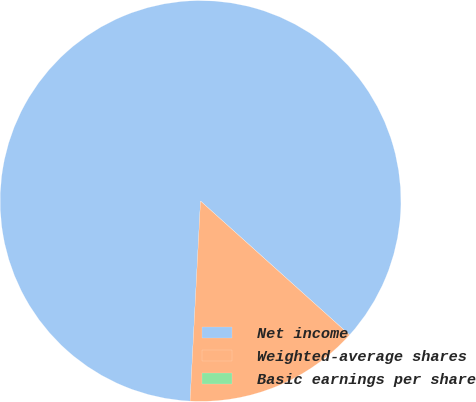Convert chart. <chart><loc_0><loc_0><loc_500><loc_500><pie_chart><fcel>Net income<fcel>Weighted-average shares<fcel>Basic earnings per share<nl><fcel>85.82%<fcel>14.18%<fcel>0.0%<nl></chart> 